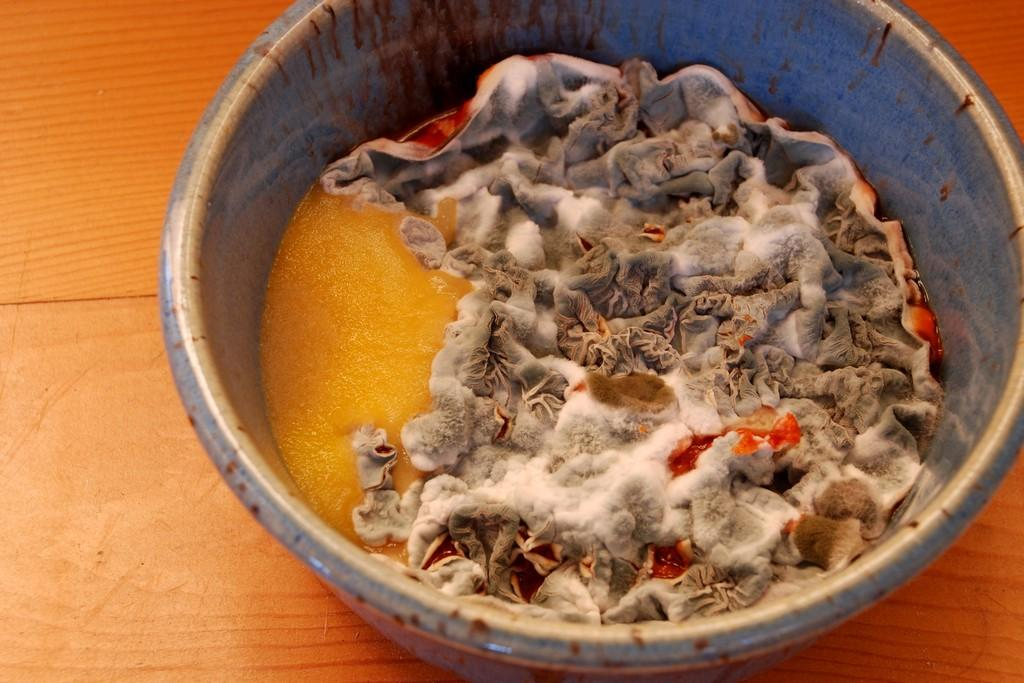What is the condition of the food item in the bowl? The food item in the bowl is moldy. What is the bowl placed on in the image? The bowl is on a wooden board. What type of car can be seen in the image? There is no car present in the image. 